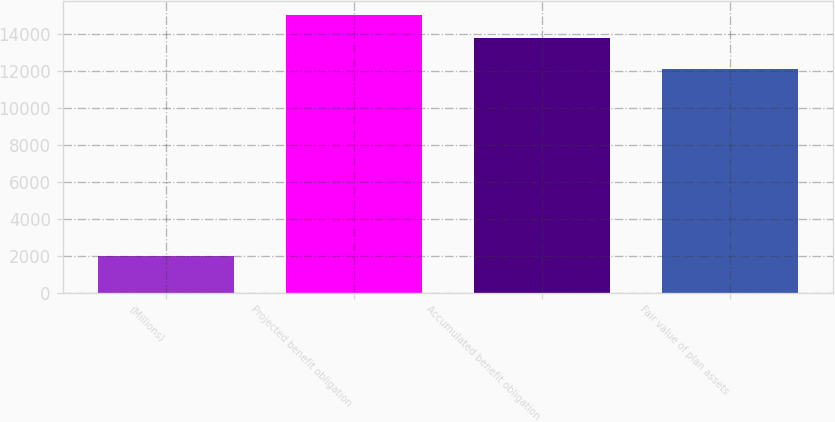Convert chart to OTSL. <chart><loc_0><loc_0><loc_500><loc_500><bar_chart><fcel>(Millions)<fcel>Projected benefit obligation<fcel>Accumulated benefit obligation<fcel>Fair value of plan assets<nl><fcel>2011<fcel>15052.8<fcel>13804<fcel>12102<nl></chart> 